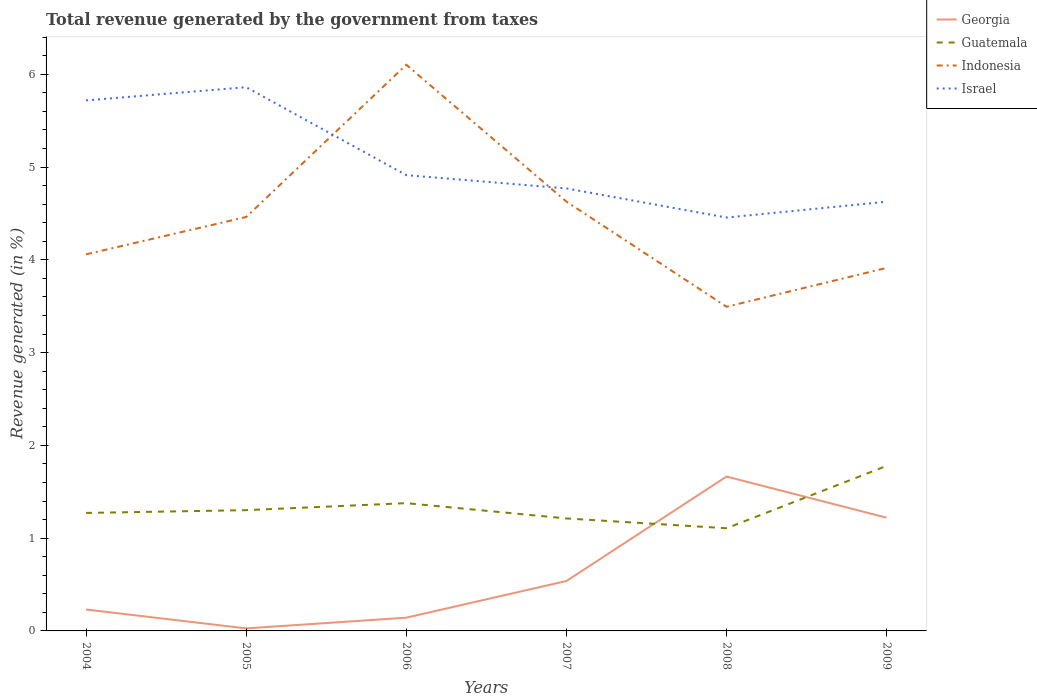How many different coloured lines are there?
Your answer should be very brief. 4. Across all years, what is the maximum total revenue generated in Georgia?
Offer a very short reply. 0.03. In which year was the total revenue generated in Israel maximum?
Make the answer very short. 2008. What is the total total revenue generated in Israel in the graph?
Your answer should be very brief. 0.95. What is the difference between the highest and the second highest total revenue generated in Indonesia?
Provide a succinct answer. 2.61. What is the difference between the highest and the lowest total revenue generated in Israel?
Offer a terse response. 2. Is the total revenue generated in Indonesia strictly greater than the total revenue generated in Israel over the years?
Provide a succinct answer. No. How many years are there in the graph?
Keep it short and to the point. 6. Are the values on the major ticks of Y-axis written in scientific E-notation?
Your answer should be compact. No. Does the graph contain any zero values?
Offer a terse response. No. Does the graph contain grids?
Offer a very short reply. No. What is the title of the graph?
Ensure brevity in your answer.  Total revenue generated by the government from taxes. What is the label or title of the X-axis?
Your answer should be very brief. Years. What is the label or title of the Y-axis?
Your response must be concise. Revenue generated (in %). What is the Revenue generated (in %) in Georgia in 2004?
Give a very brief answer. 0.23. What is the Revenue generated (in %) of Guatemala in 2004?
Make the answer very short. 1.27. What is the Revenue generated (in %) in Indonesia in 2004?
Offer a very short reply. 4.06. What is the Revenue generated (in %) of Israel in 2004?
Offer a terse response. 5.72. What is the Revenue generated (in %) of Georgia in 2005?
Offer a terse response. 0.03. What is the Revenue generated (in %) in Guatemala in 2005?
Keep it short and to the point. 1.3. What is the Revenue generated (in %) in Indonesia in 2005?
Keep it short and to the point. 4.46. What is the Revenue generated (in %) in Israel in 2005?
Your response must be concise. 5.86. What is the Revenue generated (in %) in Georgia in 2006?
Keep it short and to the point. 0.14. What is the Revenue generated (in %) of Guatemala in 2006?
Your answer should be compact. 1.38. What is the Revenue generated (in %) of Indonesia in 2006?
Keep it short and to the point. 6.1. What is the Revenue generated (in %) in Israel in 2006?
Ensure brevity in your answer.  4.91. What is the Revenue generated (in %) of Georgia in 2007?
Your response must be concise. 0.54. What is the Revenue generated (in %) of Guatemala in 2007?
Offer a terse response. 1.21. What is the Revenue generated (in %) in Indonesia in 2007?
Make the answer very short. 4.63. What is the Revenue generated (in %) of Israel in 2007?
Your answer should be compact. 4.77. What is the Revenue generated (in %) in Georgia in 2008?
Your response must be concise. 1.66. What is the Revenue generated (in %) in Guatemala in 2008?
Your answer should be compact. 1.11. What is the Revenue generated (in %) of Indonesia in 2008?
Provide a short and direct response. 3.49. What is the Revenue generated (in %) of Israel in 2008?
Offer a very short reply. 4.46. What is the Revenue generated (in %) of Georgia in 2009?
Provide a succinct answer. 1.22. What is the Revenue generated (in %) of Guatemala in 2009?
Ensure brevity in your answer.  1.78. What is the Revenue generated (in %) in Indonesia in 2009?
Give a very brief answer. 3.91. What is the Revenue generated (in %) of Israel in 2009?
Provide a short and direct response. 4.63. Across all years, what is the maximum Revenue generated (in %) of Georgia?
Keep it short and to the point. 1.66. Across all years, what is the maximum Revenue generated (in %) of Guatemala?
Provide a succinct answer. 1.78. Across all years, what is the maximum Revenue generated (in %) in Indonesia?
Your answer should be compact. 6.1. Across all years, what is the maximum Revenue generated (in %) of Israel?
Your answer should be compact. 5.86. Across all years, what is the minimum Revenue generated (in %) in Georgia?
Your answer should be compact. 0.03. Across all years, what is the minimum Revenue generated (in %) in Guatemala?
Offer a very short reply. 1.11. Across all years, what is the minimum Revenue generated (in %) in Indonesia?
Provide a succinct answer. 3.49. Across all years, what is the minimum Revenue generated (in %) of Israel?
Offer a terse response. 4.46. What is the total Revenue generated (in %) in Georgia in the graph?
Provide a short and direct response. 3.82. What is the total Revenue generated (in %) of Guatemala in the graph?
Give a very brief answer. 8.05. What is the total Revenue generated (in %) in Indonesia in the graph?
Provide a succinct answer. 26.66. What is the total Revenue generated (in %) in Israel in the graph?
Keep it short and to the point. 30.34. What is the difference between the Revenue generated (in %) in Georgia in 2004 and that in 2005?
Make the answer very short. 0.2. What is the difference between the Revenue generated (in %) in Guatemala in 2004 and that in 2005?
Keep it short and to the point. -0.03. What is the difference between the Revenue generated (in %) in Indonesia in 2004 and that in 2005?
Make the answer very short. -0.4. What is the difference between the Revenue generated (in %) in Israel in 2004 and that in 2005?
Make the answer very short. -0.14. What is the difference between the Revenue generated (in %) of Georgia in 2004 and that in 2006?
Make the answer very short. 0.09. What is the difference between the Revenue generated (in %) of Guatemala in 2004 and that in 2006?
Give a very brief answer. -0.11. What is the difference between the Revenue generated (in %) in Indonesia in 2004 and that in 2006?
Offer a very short reply. -2.04. What is the difference between the Revenue generated (in %) in Israel in 2004 and that in 2006?
Make the answer very short. 0.81. What is the difference between the Revenue generated (in %) in Georgia in 2004 and that in 2007?
Your answer should be very brief. -0.31. What is the difference between the Revenue generated (in %) in Guatemala in 2004 and that in 2007?
Your answer should be compact. 0.06. What is the difference between the Revenue generated (in %) of Indonesia in 2004 and that in 2007?
Provide a short and direct response. -0.57. What is the difference between the Revenue generated (in %) in Israel in 2004 and that in 2007?
Your answer should be compact. 0.95. What is the difference between the Revenue generated (in %) in Georgia in 2004 and that in 2008?
Provide a short and direct response. -1.43. What is the difference between the Revenue generated (in %) of Guatemala in 2004 and that in 2008?
Ensure brevity in your answer.  0.17. What is the difference between the Revenue generated (in %) in Indonesia in 2004 and that in 2008?
Make the answer very short. 0.57. What is the difference between the Revenue generated (in %) of Israel in 2004 and that in 2008?
Offer a very short reply. 1.26. What is the difference between the Revenue generated (in %) in Georgia in 2004 and that in 2009?
Offer a terse response. -0.99. What is the difference between the Revenue generated (in %) of Guatemala in 2004 and that in 2009?
Ensure brevity in your answer.  -0.51. What is the difference between the Revenue generated (in %) in Indonesia in 2004 and that in 2009?
Give a very brief answer. 0.15. What is the difference between the Revenue generated (in %) of Israel in 2004 and that in 2009?
Offer a very short reply. 1.09. What is the difference between the Revenue generated (in %) in Georgia in 2005 and that in 2006?
Give a very brief answer. -0.12. What is the difference between the Revenue generated (in %) of Guatemala in 2005 and that in 2006?
Keep it short and to the point. -0.08. What is the difference between the Revenue generated (in %) in Indonesia in 2005 and that in 2006?
Make the answer very short. -1.64. What is the difference between the Revenue generated (in %) of Israel in 2005 and that in 2006?
Provide a succinct answer. 0.95. What is the difference between the Revenue generated (in %) in Georgia in 2005 and that in 2007?
Your answer should be very brief. -0.51. What is the difference between the Revenue generated (in %) in Guatemala in 2005 and that in 2007?
Your response must be concise. 0.09. What is the difference between the Revenue generated (in %) in Indonesia in 2005 and that in 2007?
Make the answer very short. -0.17. What is the difference between the Revenue generated (in %) in Israel in 2005 and that in 2007?
Offer a terse response. 1.09. What is the difference between the Revenue generated (in %) in Georgia in 2005 and that in 2008?
Your response must be concise. -1.64. What is the difference between the Revenue generated (in %) of Guatemala in 2005 and that in 2008?
Provide a short and direct response. 0.2. What is the difference between the Revenue generated (in %) of Indonesia in 2005 and that in 2008?
Your answer should be very brief. 0.97. What is the difference between the Revenue generated (in %) of Israel in 2005 and that in 2008?
Provide a short and direct response. 1.4. What is the difference between the Revenue generated (in %) of Georgia in 2005 and that in 2009?
Your answer should be compact. -1.19. What is the difference between the Revenue generated (in %) in Guatemala in 2005 and that in 2009?
Make the answer very short. -0.48. What is the difference between the Revenue generated (in %) in Indonesia in 2005 and that in 2009?
Offer a very short reply. 0.55. What is the difference between the Revenue generated (in %) in Israel in 2005 and that in 2009?
Provide a short and direct response. 1.23. What is the difference between the Revenue generated (in %) of Georgia in 2006 and that in 2007?
Offer a terse response. -0.4. What is the difference between the Revenue generated (in %) in Guatemala in 2006 and that in 2007?
Provide a succinct answer. 0.16. What is the difference between the Revenue generated (in %) in Indonesia in 2006 and that in 2007?
Give a very brief answer. 1.47. What is the difference between the Revenue generated (in %) of Israel in 2006 and that in 2007?
Your answer should be very brief. 0.14. What is the difference between the Revenue generated (in %) in Georgia in 2006 and that in 2008?
Make the answer very short. -1.52. What is the difference between the Revenue generated (in %) in Guatemala in 2006 and that in 2008?
Your response must be concise. 0.27. What is the difference between the Revenue generated (in %) in Indonesia in 2006 and that in 2008?
Your answer should be compact. 2.61. What is the difference between the Revenue generated (in %) of Israel in 2006 and that in 2008?
Give a very brief answer. 0.46. What is the difference between the Revenue generated (in %) in Georgia in 2006 and that in 2009?
Offer a very short reply. -1.08. What is the difference between the Revenue generated (in %) of Guatemala in 2006 and that in 2009?
Give a very brief answer. -0.4. What is the difference between the Revenue generated (in %) of Indonesia in 2006 and that in 2009?
Provide a short and direct response. 2.19. What is the difference between the Revenue generated (in %) of Israel in 2006 and that in 2009?
Ensure brevity in your answer.  0.29. What is the difference between the Revenue generated (in %) of Georgia in 2007 and that in 2008?
Your answer should be very brief. -1.13. What is the difference between the Revenue generated (in %) in Guatemala in 2007 and that in 2008?
Your answer should be compact. 0.11. What is the difference between the Revenue generated (in %) in Indonesia in 2007 and that in 2008?
Provide a succinct answer. 1.13. What is the difference between the Revenue generated (in %) of Israel in 2007 and that in 2008?
Make the answer very short. 0.31. What is the difference between the Revenue generated (in %) of Georgia in 2007 and that in 2009?
Your answer should be very brief. -0.68. What is the difference between the Revenue generated (in %) in Guatemala in 2007 and that in 2009?
Offer a terse response. -0.57. What is the difference between the Revenue generated (in %) in Indonesia in 2007 and that in 2009?
Offer a very short reply. 0.71. What is the difference between the Revenue generated (in %) in Israel in 2007 and that in 2009?
Provide a short and direct response. 0.14. What is the difference between the Revenue generated (in %) of Georgia in 2008 and that in 2009?
Your answer should be very brief. 0.44. What is the difference between the Revenue generated (in %) of Guatemala in 2008 and that in 2009?
Offer a very short reply. -0.67. What is the difference between the Revenue generated (in %) in Indonesia in 2008 and that in 2009?
Your answer should be very brief. -0.42. What is the difference between the Revenue generated (in %) of Israel in 2008 and that in 2009?
Your response must be concise. -0.17. What is the difference between the Revenue generated (in %) in Georgia in 2004 and the Revenue generated (in %) in Guatemala in 2005?
Offer a terse response. -1.07. What is the difference between the Revenue generated (in %) of Georgia in 2004 and the Revenue generated (in %) of Indonesia in 2005?
Your answer should be very brief. -4.23. What is the difference between the Revenue generated (in %) of Georgia in 2004 and the Revenue generated (in %) of Israel in 2005?
Ensure brevity in your answer.  -5.63. What is the difference between the Revenue generated (in %) of Guatemala in 2004 and the Revenue generated (in %) of Indonesia in 2005?
Give a very brief answer. -3.19. What is the difference between the Revenue generated (in %) in Guatemala in 2004 and the Revenue generated (in %) in Israel in 2005?
Your answer should be compact. -4.59. What is the difference between the Revenue generated (in %) in Indonesia in 2004 and the Revenue generated (in %) in Israel in 2005?
Make the answer very short. -1.8. What is the difference between the Revenue generated (in %) of Georgia in 2004 and the Revenue generated (in %) of Guatemala in 2006?
Offer a terse response. -1.15. What is the difference between the Revenue generated (in %) in Georgia in 2004 and the Revenue generated (in %) in Indonesia in 2006?
Provide a short and direct response. -5.87. What is the difference between the Revenue generated (in %) in Georgia in 2004 and the Revenue generated (in %) in Israel in 2006?
Your answer should be very brief. -4.68. What is the difference between the Revenue generated (in %) in Guatemala in 2004 and the Revenue generated (in %) in Indonesia in 2006?
Make the answer very short. -4.83. What is the difference between the Revenue generated (in %) of Guatemala in 2004 and the Revenue generated (in %) of Israel in 2006?
Your answer should be very brief. -3.64. What is the difference between the Revenue generated (in %) in Indonesia in 2004 and the Revenue generated (in %) in Israel in 2006?
Give a very brief answer. -0.85. What is the difference between the Revenue generated (in %) in Georgia in 2004 and the Revenue generated (in %) in Guatemala in 2007?
Offer a very short reply. -0.98. What is the difference between the Revenue generated (in %) in Georgia in 2004 and the Revenue generated (in %) in Indonesia in 2007?
Your answer should be compact. -4.4. What is the difference between the Revenue generated (in %) in Georgia in 2004 and the Revenue generated (in %) in Israel in 2007?
Provide a short and direct response. -4.54. What is the difference between the Revenue generated (in %) in Guatemala in 2004 and the Revenue generated (in %) in Indonesia in 2007?
Keep it short and to the point. -3.36. What is the difference between the Revenue generated (in %) of Guatemala in 2004 and the Revenue generated (in %) of Israel in 2007?
Provide a succinct answer. -3.5. What is the difference between the Revenue generated (in %) in Indonesia in 2004 and the Revenue generated (in %) in Israel in 2007?
Your answer should be very brief. -0.71. What is the difference between the Revenue generated (in %) of Georgia in 2004 and the Revenue generated (in %) of Guatemala in 2008?
Keep it short and to the point. -0.88. What is the difference between the Revenue generated (in %) in Georgia in 2004 and the Revenue generated (in %) in Indonesia in 2008?
Provide a short and direct response. -3.26. What is the difference between the Revenue generated (in %) in Georgia in 2004 and the Revenue generated (in %) in Israel in 2008?
Keep it short and to the point. -4.22. What is the difference between the Revenue generated (in %) of Guatemala in 2004 and the Revenue generated (in %) of Indonesia in 2008?
Give a very brief answer. -2.22. What is the difference between the Revenue generated (in %) in Guatemala in 2004 and the Revenue generated (in %) in Israel in 2008?
Your answer should be very brief. -3.18. What is the difference between the Revenue generated (in %) of Indonesia in 2004 and the Revenue generated (in %) of Israel in 2008?
Offer a very short reply. -0.4. What is the difference between the Revenue generated (in %) of Georgia in 2004 and the Revenue generated (in %) of Guatemala in 2009?
Your answer should be very brief. -1.55. What is the difference between the Revenue generated (in %) in Georgia in 2004 and the Revenue generated (in %) in Indonesia in 2009?
Offer a terse response. -3.68. What is the difference between the Revenue generated (in %) in Georgia in 2004 and the Revenue generated (in %) in Israel in 2009?
Your answer should be very brief. -4.4. What is the difference between the Revenue generated (in %) of Guatemala in 2004 and the Revenue generated (in %) of Indonesia in 2009?
Make the answer very short. -2.64. What is the difference between the Revenue generated (in %) in Guatemala in 2004 and the Revenue generated (in %) in Israel in 2009?
Keep it short and to the point. -3.35. What is the difference between the Revenue generated (in %) of Indonesia in 2004 and the Revenue generated (in %) of Israel in 2009?
Your response must be concise. -0.57. What is the difference between the Revenue generated (in %) in Georgia in 2005 and the Revenue generated (in %) in Guatemala in 2006?
Provide a succinct answer. -1.35. What is the difference between the Revenue generated (in %) in Georgia in 2005 and the Revenue generated (in %) in Indonesia in 2006?
Provide a short and direct response. -6.08. What is the difference between the Revenue generated (in %) in Georgia in 2005 and the Revenue generated (in %) in Israel in 2006?
Offer a very short reply. -4.89. What is the difference between the Revenue generated (in %) in Guatemala in 2005 and the Revenue generated (in %) in Indonesia in 2006?
Make the answer very short. -4.8. What is the difference between the Revenue generated (in %) in Guatemala in 2005 and the Revenue generated (in %) in Israel in 2006?
Your response must be concise. -3.61. What is the difference between the Revenue generated (in %) of Indonesia in 2005 and the Revenue generated (in %) of Israel in 2006?
Offer a very short reply. -0.45. What is the difference between the Revenue generated (in %) of Georgia in 2005 and the Revenue generated (in %) of Guatemala in 2007?
Your answer should be compact. -1.19. What is the difference between the Revenue generated (in %) of Georgia in 2005 and the Revenue generated (in %) of Indonesia in 2007?
Keep it short and to the point. -4.6. What is the difference between the Revenue generated (in %) of Georgia in 2005 and the Revenue generated (in %) of Israel in 2007?
Provide a succinct answer. -4.74. What is the difference between the Revenue generated (in %) of Guatemala in 2005 and the Revenue generated (in %) of Indonesia in 2007?
Your answer should be very brief. -3.33. What is the difference between the Revenue generated (in %) of Guatemala in 2005 and the Revenue generated (in %) of Israel in 2007?
Give a very brief answer. -3.47. What is the difference between the Revenue generated (in %) of Indonesia in 2005 and the Revenue generated (in %) of Israel in 2007?
Offer a terse response. -0.31. What is the difference between the Revenue generated (in %) of Georgia in 2005 and the Revenue generated (in %) of Guatemala in 2008?
Make the answer very short. -1.08. What is the difference between the Revenue generated (in %) in Georgia in 2005 and the Revenue generated (in %) in Indonesia in 2008?
Provide a short and direct response. -3.47. What is the difference between the Revenue generated (in %) in Georgia in 2005 and the Revenue generated (in %) in Israel in 2008?
Your response must be concise. -4.43. What is the difference between the Revenue generated (in %) in Guatemala in 2005 and the Revenue generated (in %) in Indonesia in 2008?
Give a very brief answer. -2.19. What is the difference between the Revenue generated (in %) in Guatemala in 2005 and the Revenue generated (in %) in Israel in 2008?
Offer a very short reply. -3.15. What is the difference between the Revenue generated (in %) in Indonesia in 2005 and the Revenue generated (in %) in Israel in 2008?
Offer a very short reply. 0.01. What is the difference between the Revenue generated (in %) of Georgia in 2005 and the Revenue generated (in %) of Guatemala in 2009?
Provide a short and direct response. -1.75. What is the difference between the Revenue generated (in %) in Georgia in 2005 and the Revenue generated (in %) in Indonesia in 2009?
Offer a very short reply. -3.89. What is the difference between the Revenue generated (in %) of Georgia in 2005 and the Revenue generated (in %) of Israel in 2009?
Give a very brief answer. -4.6. What is the difference between the Revenue generated (in %) in Guatemala in 2005 and the Revenue generated (in %) in Indonesia in 2009?
Ensure brevity in your answer.  -2.61. What is the difference between the Revenue generated (in %) of Guatemala in 2005 and the Revenue generated (in %) of Israel in 2009?
Keep it short and to the point. -3.32. What is the difference between the Revenue generated (in %) of Indonesia in 2005 and the Revenue generated (in %) of Israel in 2009?
Make the answer very short. -0.16. What is the difference between the Revenue generated (in %) of Georgia in 2006 and the Revenue generated (in %) of Guatemala in 2007?
Ensure brevity in your answer.  -1.07. What is the difference between the Revenue generated (in %) in Georgia in 2006 and the Revenue generated (in %) in Indonesia in 2007?
Provide a short and direct response. -4.48. What is the difference between the Revenue generated (in %) in Georgia in 2006 and the Revenue generated (in %) in Israel in 2007?
Make the answer very short. -4.63. What is the difference between the Revenue generated (in %) in Guatemala in 2006 and the Revenue generated (in %) in Indonesia in 2007?
Give a very brief answer. -3.25. What is the difference between the Revenue generated (in %) in Guatemala in 2006 and the Revenue generated (in %) in Israel in 2007?
Your answer should be very brief. -3.39. What is the difference between the Revenue generated (in %) in Indonesia in 2006 and the Revenue generated (in %) in Israel in 2007?
Ensure brevity in your answer.  1.33. What is the difference between the Revenue generated (in %) in Georgia in 2006 and the Revenue generated (in %) in Guatemala in 2008?
Your answer should be compact. -0.96. What is the difference between the Revenue generated (in %) in Georgia in 2006 and the Revenue generated (in %) in Indonesia in 2008?
Your response must be concise. -3.35. What is the difference between the Revenue generated (in %) of Georgia in 2006 and the Revenue generated (in %) of Israel in 2008?
Your response must be concise. -4.31. What is the difference between the Revenue generated (in %) in Guatemala in 2006 and the Revenue generated (in %) in Indonesia in 2008?
Ensure brevity in your answer.  -2.12. What is the difference between the Revenue generated (in %) in Guatemala in 2006 and the Revenue generated (in %) in Israel in 2008?
Your answer should be very brief. -3.08. What is the difference between the Revenue generated (in %) in Indonesia in 2006 and the Revenue generated (in %) in Israel in 2008?
Your response must be concise. 1.65. What is the difference between the Revenue generated (in %) in Georgia in 2006 and the Revenue generated (in %) in Guatemala in 2009?
Your answer should be very brief. -1.64. What is the difference between the Revenue generated (in %) of Georgia in 2006 and the Revenue generated (in %) of Indonesia in 2009?
Provide a short and direct response. -3.77. What is the difference between the Revenue generated (in %) of Georgia in 2006 and the Revenue generated (in %) of Israel in 2009?
Make the answer very short. -4.48. What is the difference between the Revenue generated (in %) in Guatemala in 2006 and the Revenue generated (in %) in Indonesia in 2009?
Make the answer very short. -2.54. What is the difference between the Revenue generated (in %) of Guatemala in 2006 and the Revenue generated (in %) of Israel in 2009?
Your answer should be very brief. -3.25. What is the difference between the Revenue generated (in %) of Indonesia in 2006 and the Revenue generated (in %) of Israel in 2009?
Offer a terse response. 1.48. What is the difference between the Revenue generated (in %) in Georgia in 2007 and the Revenue generated (in %) in Guatemala in 2008?
Provide a short and direct response. -0.57. What is the difference between the Revenue generated (in %) of Georgia in 2007 and the Revenue generated (in %) of Indonesia in 2008?
Offer a very short reply. -2.96. What is the difference between the Revenue generated (in %) in Georgia in 2007 and the Revenue generated (in %) in Israel in 2008?
Your answer should be compact. -3.92. What is the difference between the Revenue generated (in %) of Guatemala in 2007 and the Revenue generated (in %) of Indonesia in 2008?
Keep it short and to the point. -2.28. What is the difference between the Revenue generated (in %) of Guatemala in 2007 and the Revenue generated (in %) of Israel in 2008?
Provide a short and direct response. -3.24. What is the difference between the Revenue generated (in %) in Indonesia in 2007 and the Revenue generated (in %) in Israel in 2008?
Offer a very short reply. 0.17. What is the difference between the Revenue generated (in %) in Georgia in 2007 and the Revenue generated (in %) in Guatemala in 2009?
Your response must be concise. -1.24. What is the difference between the Revenue generated (in %) in Georgia in 2007 and the Revenue generated (in %) in Indonesia in 2009?
Your answer should be compact. -3.37. What is the difference between the Revenue generated (in %) in Georgia in 2007 and the Revenue generated (in %) in Israel in 2009?
Offer a terse response. -4.09. What is the difference between the Revenue generated (in %) of Guatemala in 2007 and the Revenue generated (in %) of Indonesia in 2009?
Provide a short and direct response. -2.7. What is the difference between the Revenue generated (in %) in Guatemala in 2007 and the Revenue generated (in %) in Israel in 2009?
Ensure brevity in your answer.  -3.41. What is the difference between the Revenue generated (in %) in Indonesia in 2007 and the Revenue generated (in %) in Israel in 2009?
Offer a terse response. 0. What is the difference between the Revenue generated (in %) in Georgia in 2008 and the Revenue generated (in %) in Guatemala in 2009?
Provide a succinct answer. -0.12. What is the difference between the Revenue generated (in %) of Georgia in 2008 and the Revenue generated (in %) of Indonesia in 2009?
Your answer should be very brief. -2.25. What is the difference between the Revenue generated (in %) of Georgia in 2008 and the Revenue generated (in %) of Israel in 2009?
Make the answer very short. -2.96. What is the difference between the Revenue generated (in %) of Guatemala in 2008 and the Revenue generated (in %) of Indonesia in 2009?
Your response must be concise. -2.81. What is the difference between the Revenue generated (in %) of Guatemala in 2008 and the Revenue generated (in %) of Israel in 2009?
Offer a very short reply. -3.52. What is the difference between the Revenue generated (in %) in Indonesia in 2008 and the Revenue generated (in %) in Israel in 2009?
Ensure brevity in your answer.  -1.13. What is the average Revenue generated (in %) of Georgia per year?
Your response must be concise. 0.64. What is the average Revenue generated (in %) in Guatemala per year?
Your answer should be compact. 1.34. What is the average Revenue generated (in %) of Indonesia per year?
Your response must be concise. 4.44. What is the average Revenue generated (in %) of Israel per year?
Provide a short and direct response. 5.06. In the year 2004, what is the difference between the Revenue generated (in %) of Georgia and Revenue generated (in %) of Guatemala?
Provide a short and direct response. -1.04. In the year 2004, what is the difference between the Revenue generated (in %) in Georgia and Revenue generated (in %) in Indonesia?
Keep it short and to the point. -3.83. In the year 2004, what is the difference between the Revenue generated (in %) in Georgia and Revenue generated (in %) in Israel?
Your answer should be compact. -5.49. In the year 2004, what is the difference between the Revenue generated (in %) in Guatemala and Revenue generated (in %) in Indonesia?
Give a very brief answer. -2.79. In the year 2004, what is the difference between the Revenue generated (in %) of Guatemala and Revenue generated (in %) of Israel?
Keep it short and to the point. -4.45. In the year 2004, what is the difference between the Revenue generated (in %) in Indonesia and Revenue generated (in %) in Israel?
Your answer should be very brief. -1.66. In the year 2005, what is the difference between the Revenue generated (in %) of Georgia and Revenue generated (in %) of Guatemala?
Your response must be concise. -1.27. In the year 2005, what is the difference between the Revenue generated (in %) of Georgia and Revenue generated (in %) of Indonesia?
Ensure brevity in your answer.  -4.43. In the year 2005, what is the difference between the Revenue generated (in %) of Georgia and Revenue generated (in %) of Israel?
Your response must be concise. -5.83. In the year 2005, what is the difference between the Revenue generated (in %) in Guatemala and Revenue generated (in %) in Indonesia?
Offer a terse response. -3.16. In the year 2005, what is the difference between the Revenue generated (in %) of Guatemala and Revenue generated (in %) of Israel?
Make the answer very short. -4.56. In the year 2005, what is the difference between the Revenue generated (in %) in Indonesia and Revenue generated (in %) in Israel?
Provide a succinct answer. -1.4. In the year 2006, what is the difference between the Revenue generated (in %) in Georgia and Revenue generated (in %) in Guatemala?
Offer a terse response. -1.23. In the year 2006, what is the difference between the Revenue generated (in %) of Georgia and Revenue generated (in %) of Indonesia?
Give a very brief answer. -5.96. In the year 2006, what is the difference between the Revenue generated (in %) in Georgia and Revenue generated (in %) in Israel?
Offer a very short reply. -4.77. In the year 2006, what is the difference between the Revenue generated (in %) in Guatemala and Revenue generated (in %) in Indonesia?
Make the answer very short. -4.73. In the year 2006, what is the difference between the Revenue generated (in %) in Guatemala and Revenue generated (in %) in Israel?
Offer a terse response. -3.54. In the year 2006, what is the difference between the Revenue generated (in %) in Indonesia and Revenue generated (in %) in Israel?
Provide a short and direct response. 1.19. In the year 2007, what is the difference between the Revenue generated (in %) in Georgia and Revenue generated (in %) in Guatemala?
Your answer should be very brief. -0.67. In the year 2007, what is the difference between the Revenue generated (in %) of Georgia and Revenue generated (in %) of Indonesia?
Provide a succinct answer. -4.09. In the year 2007, what is the difference between the Revenue generated (in %) of Georgia and Revenue generated (in %) of Israel?
Your answer should be compact. -4.23. In the year 2007, what is the difference between the Revenue generated (in %) of Guatemala and Revenue generated (in %) of Indonesia?
Provide a short and direct response. -3.42. In the year 2007, what is the difference between the Revenue generated (in %) of Guatemala and Revenue generated (in %) of Israel?
Offer a terse response. -3.56. In the year 2007, what is the difference between the Revenue generated (in %) in Indonesia and Revenue generated (in %) in Israel?
Provide a short and direct response. -0.14. In the year 2008, what is the difference between the Revenue generated (in %) in Georgia and Revenue generated (in %) in Guatemala?
Make the answer very short. 0.56. In the year 2008, what is the difference between the Revenue generated (in %) in Georgia and Revenue generated (in %) in Indonesia?
Make the answer very short. -1.83. In the year 2008, what is the difference between the Revenue generated (in %) in Georgia and Revenue generated (in %) in Israel?
Provide a succinct answer. -2.79. In the year 2008, what is the difference between the Revenue generated (in %) in Guatemala and Revenue generated (in %) in Indonesia?
Your answer should be very brief. -2.39. In the year 2008, what is the difference between the Revenue generated (in %) in Guatemala and Revenue generated (in %) in Israel?
Give a very brief answer. -3.35. In the year 2008, what is the difference between the Revenue generated (in %) of Indonesia and Revenue generated (in %) of Israel?
Offer a terse response. -0.96. In the year 2009, what is the difference between the Revenue generated (in %) in Georgia and Revenue generated (in %) in Guatemala?
Offer a terse response. -0.56. In the year 2009, what is the difference between the Revenue generated (in %) in Georgia and Revenue generated (in %) in Indonesia?
Offer a terse response. -2.69. In the year 2009, what is the difference between the Revenue generated (in %) of Georgia and Revenue generated (in %) of Israel?
Provide a succinct answer. -3.41. In the year 2009, what is the difference between the Revenue generated (in %) of Guatemala and Revenue generated (in %) of Indonesia?
Ensure brevity in your answer.  -2.13. In the year 2009, what is the difference between the Revenue generated (in %) in Guatemala and Revenue generated (in %) in Israel?
Offer a very short reply. -2.85. In the year 2009, what is the difference between the Revenue generated (in %) in Indonesia and Revenue generated (in %) in Israel?
Give a very brief answer. -0.71. What is the ratio of the Revenue generated (in %) of Georgia in 2004 to that in 2005?
Offer a very short reply. 8.51. What is the ratio of the Revenue generated (in %) in Indonesia in 2004 to that in 2005?
Ensure brevity in your answer.  0.91. What is the ratio of the Revenue generated (in %) of Israel in 2004 to that in 2005?
Ensure brevity in your answer.  0.98. What is the ratio of the Revenue generated (in %) in Georgia in 2004 to that in 2006?
Ensure brevity in your answer.  1.62. What is the ratio of the Revenue generated (in %) in Guatemala in 2004 to that in 2006?
Your answer should be compact. 0.92. What is the ratio of the Revenue generated (in %) of Indonesia in 2004 to that in 2006?
Your answer should be very brief. 0.67. What is the ratio of the Revenue generated (in %) in Israel in 2004 to that in 2006?
Offer a very short reply. 1.16. What is the ratio of the Revenue generated (in %) in Georgia in 2004 to that in 2007?
Make the answer very short. 0.43. What is the ratio of the Revenue generated (in %) of Guatemala in 2004 to that in 2007?
Provide a short and direct response. 1.05. What is the ratio of the Revenue generated (in %) of Indonesia in 2004 to that in 2007?
Offer a terse response. 0.88. What is the ratio of the Revenue generated (in %) of Israel in 2004 to that in 2007?
Your response must be concise. 1.2. What is the ratio of the Revenue generated (in %) in Georgia in 2004 to that in 2008?
Provide a succinct answer. 0.14. What is the ratio of the Revenue generated (in %) of Guatemala in 2004 to that in 2008?
Make the answer very short. 1.15. What is the ratio of the Revenue generated (in %) in Indonesia in 2004 to that in 2008?
Offer a very short reply. 1.16. What is the ratio of the Revenue generated (in %) of Israel in 2004 to that in 2008?
Offer a terse response. 1.28. What is the ratio of the Revenue generated (in %) in Georgia in 2004 to that in 2009?
Your response must be concise. 0.19. What is the ratio of the Revenue generated (in %) of Guatemala in 2004 to that in 2009?
Give a very brief answer. 0.71. What is the ratio of the Revenue generated (in %) of Indonesia in 2004 to that in 2009?
Your answer should be very brief. 1.04. What is the ratio of the Revenue generated (in %) in Israel in 2004 to that in 2009?
Your response must be concise. 1.24. What is the ratio of the Revenue generated (in %) in Georgia in 2005 to that in 2006?
Provide a short and direct response. 0.19. What is the ratio of the Revenue generated (in %) of Guatemala in 2005 to that in 2006?
Your response must be concise. 0.95. What is the ratio of the Revenue generated (in %) of Indonesia in 2005 to that in 2006?
Keep it short and to the point. 0.73. What is the ratio of the Revenue generated (in %) in Israel in 2005 to that in 2006?
Your response must be concise. 1.19. What is the ratio of the Revenue generated (in %) of Georgia in 2005 to that in 2007?
Ensure brevity in your answer.  0.05. What is the ratio of the Revenue generated (in %) of Guatemala in 2005 to that in 2007?
Provide a short and direct response. 1.07. What is the ratio of the Revenue generated (in %) in Indonesia in 2005 to that in 2007?
Ensure brevity in your answer.  0.96. What is the ratio of the Revenue generated (in %) of Israel in 2005 to that in 2007?
Offer a terse response. 1.23. What is the ratio of the Revenue generated (in %) of Georgia in 2005 to that in 2008?
Ensure brevity in your answer.  0.02. What is the ratio of the Revenue generated (in %) of Guatemala in 2005 to that in 2008?
Your answer should be compact. 1.18. What is the ratio of the Revenue generated (in %) in Indonesia in 2005 to that in 2008?
Ensure brevity in your answer.  1.28. What is the ratio of the Revenue generated (in %) in Israel in 2005 to that in 2008?
Make the answer very short. 1.32. What is the ratio of the Revenue generated (in %) of Georgia in 2005 to that in 2009?
Your answer should be compact. 0.02. What is the ratio of the Revenue generated (in %) in Guatemala in 2005 to that in 2009?
Ensure brevity in your answer.  0.73. What is the ratio of the Revenue generated (in %) in Indonesia in 2005 to that in 2009?
Offer a terse response. 1.14. What is the ratio of the Revenue generated (in %) of Israel in 2005 to that in 2009?
Make the answer very short. 1.27. What is the ratio of the Revenue generated (in %) in Georgia in 2006 to that in 2007?
Offer a very short reply. 0.27. What is the ratio of the Revenue generated (in %) of Guatemala in 2006 to that in 2007?
Offer a very short reply. 1.14. What is the ratio of the Revenue generated (in %) of Indonesia in 2006 to that in 2007?
Make the answer very short. 1.32. What is the ratio of the Revenue generated (in %) in Georgia in 2006 to that in 2008?
Offer a terse response. 0.09. What is the ratio of the Revenue generated (in %) in Guatemala in 2006 to that in 2008?
Your response must be concise. 1.24. What is the ratio of the Revenue generated (in %) in Indonesia in 2006 to that in 2008?
Offer a very short reply. 1.75. What is the ratio of the Revenue generated (in %) in Israel in 2006 to that in 2008?
Keep it short and to the point. 1.1. What is the ratio of the Revenue generated (in %) of Georgia in 2006 to that in 2009?
Provide a short and direct response. 0.12. What is the ratio of the Revenue generated (in %) in Guatemala in 2006 to that in 2009?
Your response must be concise. 0.77. What is the ratio of the Revenue generated (in %) in Indonesia in 2006 to that in 2009?
Make the answer very short. 1.56. What is the ratio of the Revenue generated (in %) of Israel in 2006 to that in 2009?
Provide a succinct answer. 1.06. What is the ratio of the Revenue generated (in %) of Georgia in 2007 to that in 2008?
Your response must be concise. 0.32. What is the ratio of the Revenue generated (in %) in Guatemala in 2007 to that in 2008?
Offer a terse response. 1.1. What is the ratio of the Revenue generated (in %) of Indonesia in 2007 to that in 2008?
Ensure brevity in your answer.  1.32. What is the ratio of the Revenue generated (in %) of Israel in 2007 to that in 2008?
Offer a very short reply. 1.07. What is the ratio of the Revenue generated (in %) in Georgia in 2007 to that in 2009?
Ensure brevity in your answer.  0.44. What is the ratio of the Revenue generated (in %) in Guatemala in 2007 to that in 2009?
Your response must be concise. 0.68. What is the ratio of the Revenue generated (in %) of Indonesia in 2007 to that in 2009?
Your answer should be compact. 1.18. What is the ratio of the Revenue generated (in %) of Israel in 2007 to that in 2009?
Provide a succinct answer. 1.03. What is the ratio of the Revenue generated (in %) of Georgia in 2008 to that in 2009?
Your answer should be very brief. 1.36. What is the ratio of the Revenue generated (in %) in Guatemala in 2008 to that in 2009?
Provide a succinct answer. 0.62. What is the ratio of the Revenue generated (in %) of Indonesia in 2008 to that in 2009?
Make the answer very short. 0.89. What is the ratio of the Revenue generated (in %) of Israel in 2008 to that in 2009?
Give a very brief answer. 0.96. What is the difference between the highest and the second highest Revenue generated (in %) in Georgia?
Provide a succinct answer. 0.44. What is the difference between the highest and the second highest Revenue generated (in %) of Guatemala?
Offer a very short reply. 0.4. What is the difference between the highest and the second highest Revenue generated (in %) of Indonesia?
Your response must be concise. 1.47. What is the difference between the highest and the second highest Revenue generated (in %) of Israel?
Your answer should be compact. 0.14. What is the difference between the highest and the lowest Revenue generated (in %) of Georgia?
Give a very brief answer. 1.64. What is the difference between the highest and the lowest Revenue generated (in %) of Guatemala?
Your response must be concise. 0.67. What is the difference between the highest and the lowest Revenue generated (in %) in Indonesia?
Your response must be concise. 2.61. What is the difference between the highest and the lowest Revenue generated (in %) of Israel?
Provide a succinct answer. 1.4. 